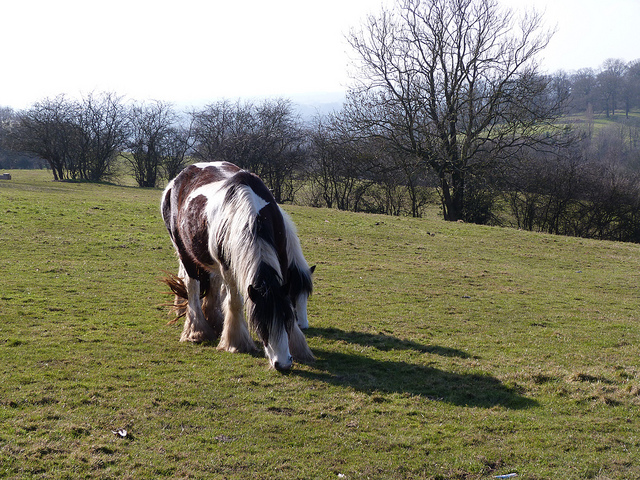Suppose the horse could talk. What story might it tell about its day? If the horse could talk, it might share a tale of tranquility and simple pleasures. It could describe the crisp morning air as it wandered through the pasture, the taste of fresh grass, and the camaraderie with nearby wildlife. As the sun climbed higher, it would recount finding a shady spot to rest and ponder the rolling hills. With twilight approaching, it might express a sense of contentment and connection to the timeless beauty of its surroundings. Imagine this place a hundred years from now. Paint a picture of its future. A hundred years from now, this pasture might remain a sanctuary of nature, preserved as part of a larger conservation effort. Ancient trees stand tall and majestic, their branches forming a verdant canopy. Wildflowers pepper the landscape in vibrant colors, and a meandering stream provides life to countless species. The horse’s descendants roam freely, embodying the spirit of their ancestor. Signposts along pathways tell the history of this haven, educating visitors about its ecological and cultural significance. On the horizon, a sustainable community thrives harmoniously with nature, respecting the beauty and balance of the land. 